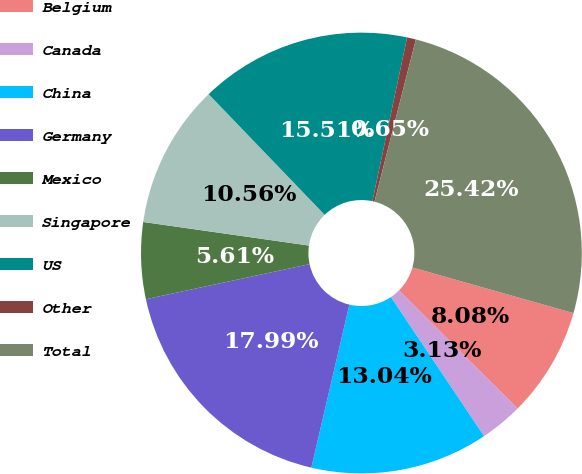Convert chart to OTSL. <chart><loc_0><loc_0><loc_500><loc_500><pie_chart><fcel>Belgium<fcel>Canada<fcel>China<fcel>Germany<fcel>Mexico<fcel>Singapore<fcel>US<fcel>Other<fcel>Total<nl><fcel>8.08%<fcel>3.13%<fcel>13.04%<fcel>17.99%<fcel>5.61%<fcel>10.56%<fcel>15.51%<fcel>0.65%<fcel>25.42%<nl></chart> 